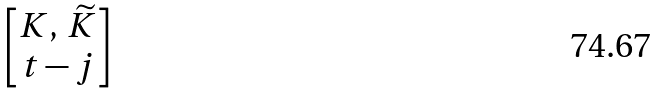Convert formula to latex. <formula><loc_0><loc_0><loc_500><loc_500>\begin{bmatrix} K , \, \widetilde { K } \\ t - j \end{bmatrix}</formula> 